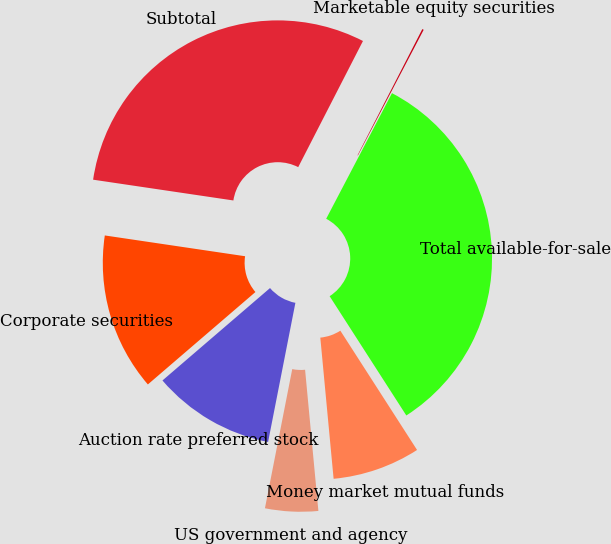<chart> <loc_0><loc_0><loc_500><loc_500><pie_chart><fcel>Money market mutual funds<fcel>US government and agency<fcel>Auction rate preferred stock<fcel>Corporate securities<fcel>Subtotal<fcel>Marketable equity securities<fcel>Total available-for-sale<nl><fcel>7.6%<fcel>4.58%<fcel>10.62%<fcel>13.64%<fcel>30.21%<fcel>0.13%<fcel>33.23%<nl></chart> 